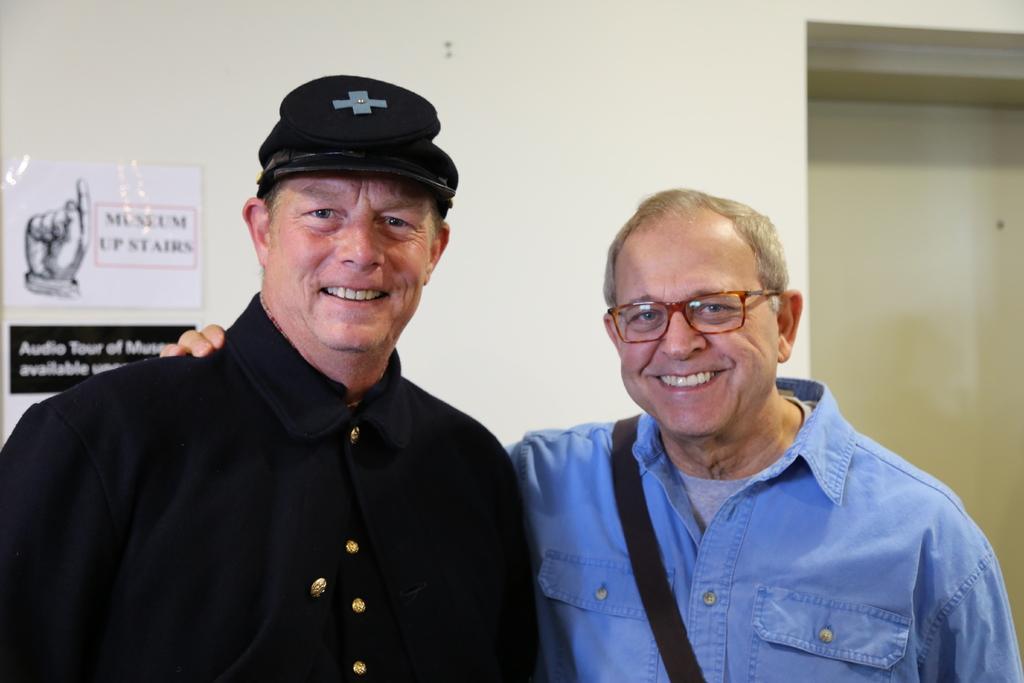Please provide a concise description of this image. In this picture we can see there are two people standing and smiling. Behind the people there is a wall with a poster and a board. 